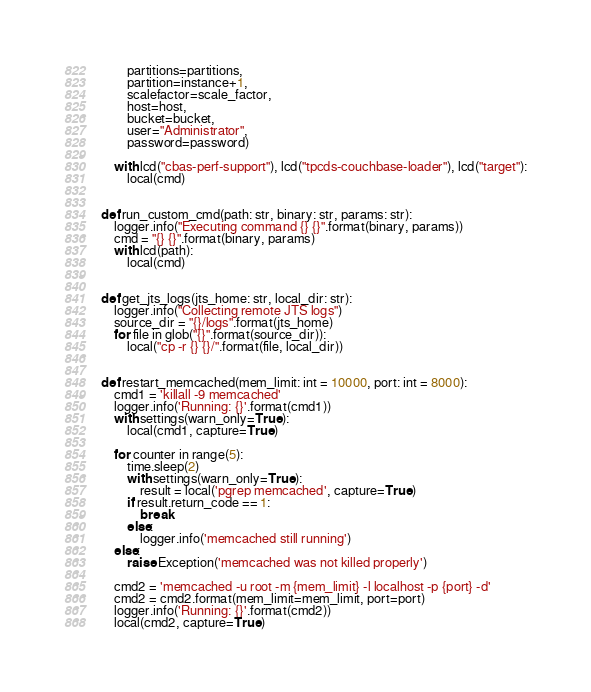<code> <loc_0><loc_0><loc_500><loc_500><_Python_>        partitions=partitions,
        partition=instance+1,
        scalefactor=scale_factor,
        host=host,
        bucket=bucket,
        user="Administrator",
        password=password)

    with lcd("cbas-perf-support"), lcd("tpcds-couchbase-loader"), lcd("target"):
        local(cmd)


def run_custom_cmd(path: str, binary: str, params: str):
    logger.info("Executing command {} {}".format(binary, params))
    cmd = "{} {}".format(binary, params)
    with lcd(path):
        local(cmd)


def get_jts_logs(jts_home: str, local_dir: str):
    logger.info("Collecting remote JTS logs")
    source_dir = "{}/logs".format(jts_home)
    for file in glob("{}".format(source_dir)):
        local("cp -r {} {}/".format(file, local_dir))


def restart_memcached(mem_limit: int = 10000, port: int = 8000):
    cmd1 = 'killall -9 memcached'
    logger.info('Running: {}'.format(cmd1))
    with settings(warn_only=True):
        local(cmd1, capture=True)

    for counter in range(5):
        time.sleep(2)
        with settings(warn_only=True):
            result = local('pgrep memcached', capture=True)
        if result.return_code == 1:
            break
        else:
            logger.info('memcached still running')
    else:
        raise Exception('memcached was not killed properly')

    cmd2 = 'memcached -u root -m {mem_limit} -l localhost -p {port} -d'
    cmd2 = cmd2.format(mem_limit=mem_limit, port=port)
    logger.info('Running: {}'.format(cmd2))
    local(cmd2, capture=True)
</code> 